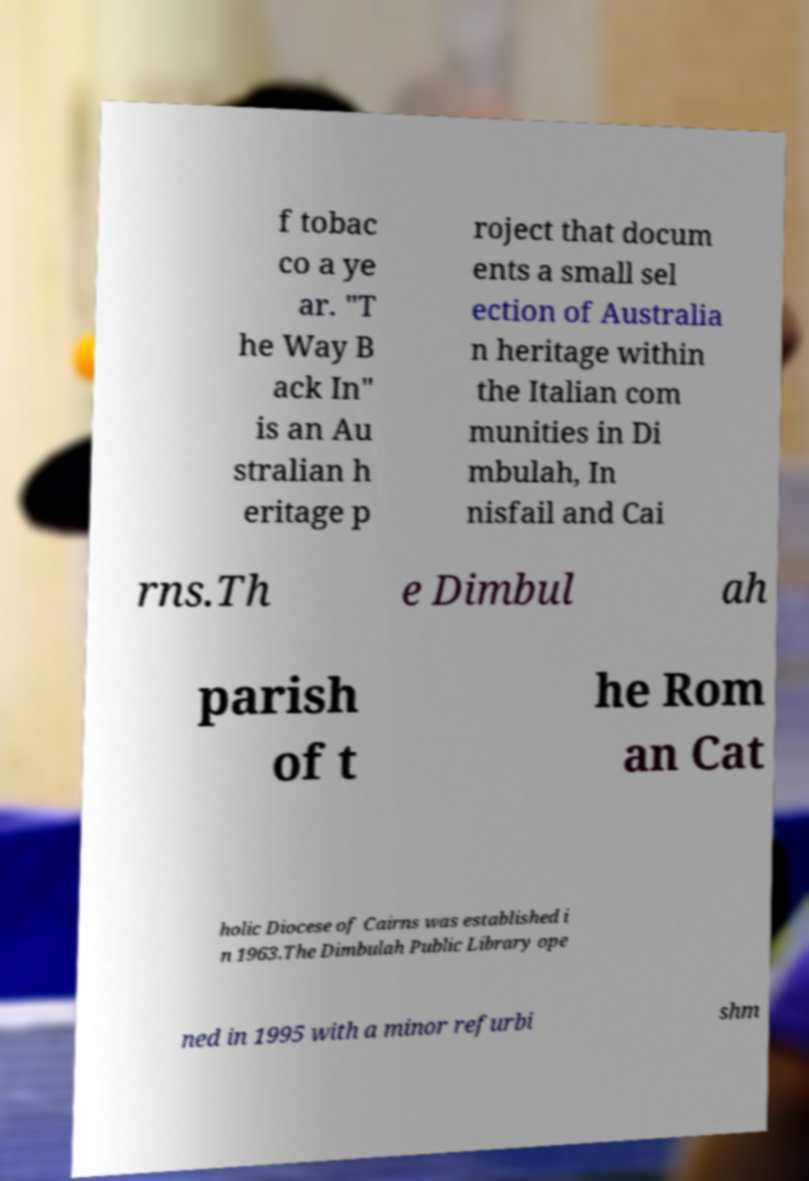Please read and relay the text visible in this image. What does it say? f tobac co a ye ar. "T he Way B ack In" is an Au stralian h eritage p roject that docum ents a small sel ection of Australia n heritage within the Italian com munities in Di mbulah, In nisfail and Cai rns.Th e Dimbul ah parish of t he Rom an Cat holic Diocese of Cairns was established i n 1963.The Dimbulah Public Library ope ned in 1995 with a minor refurbi shm 